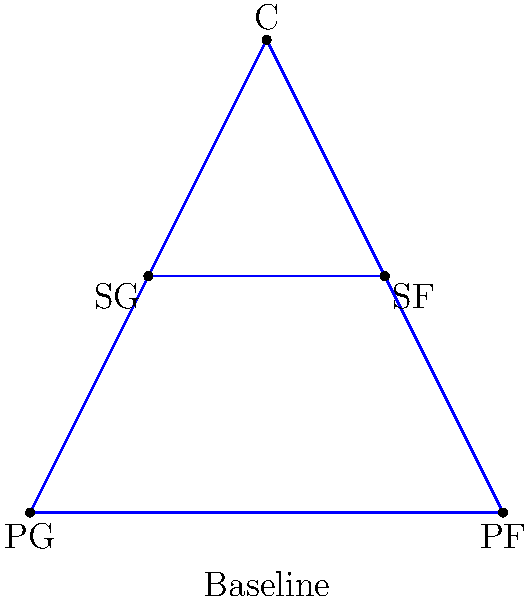In this traditional basketball play formation, which player position is typically responsible for initiating the offense and is located at the bottom center of the diagram? To answer this question, let's analyze the positions in a traditional basketball formation:

1. The diagram shows a standard half-court setup with five player positions.
2. In basketball, there are five main positions: Point Guard (PG), Shooting Guard (SG), Small Forward (SF), Power Forward (PF), and Center (C).
3. The Point Guard is typically responsible for initiating the offense and controlling the ball.
4. In this diagram, we can see that the PG is positioned at the bottom center, closest to the baseline.
5. This positioning allows the PG to have a clear view of the court and orchestrate the team's offensive plays.
6. The other positions are arranged around the court, with the Center (C) at the top of the key, the Power Forward (PF) on one corner of the baseline, and the Shooting Guard (SG) and Small Forward (SF) on the wings.

Given this traditional setup and the responsibilities of each position, the player at the bottom center of the diagram, labeled "PG," is the Point Guard.
Answer: Point Guard (PG) 